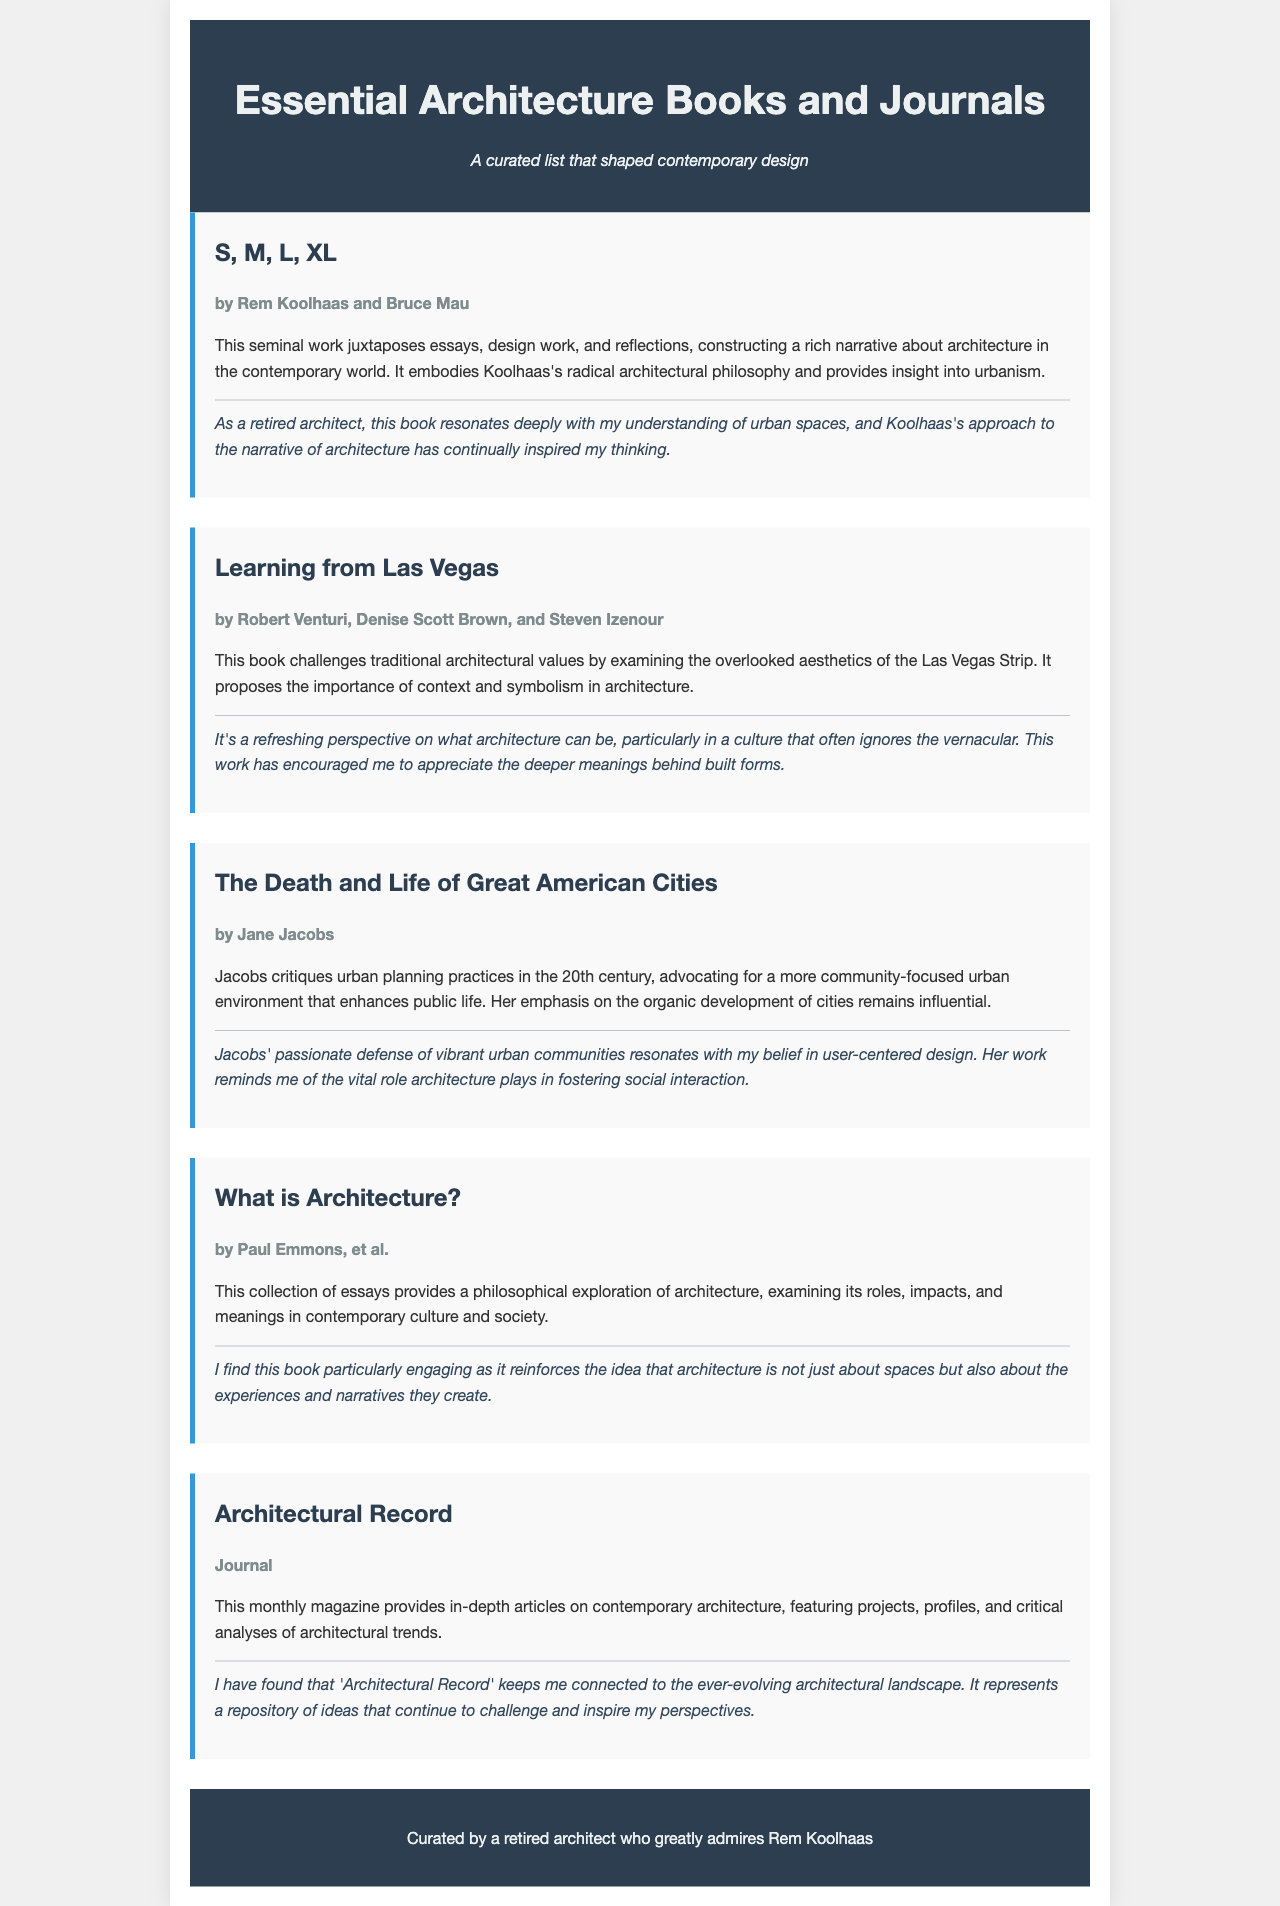What is the title of the book by Rem Koolhaas? The title of the book authored by Rem Koolhaas is prominently mentioned in the document under his section.
Answer: S, M, L, XL Who co-authored "Learning from Las Vegas"? The authors of "Learning from Las Vegas" are listed in the document, which specifies Robert Venturi, Denise Scott Brown, and Steven Izenour as the creators of this work.
Answer: Robert Venturi, Denise Scott Brown, and Steven Izenour What is the main focus of "The Death and Life of Great American Cities"? The document summarizes this work with a focus on critiquing urban planning and emphasizing community in urban environments; hence, it can be deduced.
Answer: Community-focused urban environment Which journal is mentioned in the document? The document includes the name of a monthly publication that features articles on contemporary architecture, specifically noted as a journal.
Answer: Architectural Record What theme is recurrent in the reflections of the book summaries? Each reflection expresses a connection between architecture and a certain concept or aspect, providing insight into the author's perspective about architecture's impact.
Answer: User-centered design How many authors are mentioned for "What is Architecture?" The document explicitly states that "What is Architecture?" is authored by Paul Emmons et al., which indicates the presence of multiple authors.
Answer: Multiple authors What is the unique feature of the book "S, M, L, XL"? The document describes "S, M, L, XL" as a work that juxtaposes different elements, signifying a unique structural narrative style.
Answer: Juxtaposes essays, design work, and reflections What is the publication frequency of "Architectural Record"? Within the document, it specifies the frequency of this journal, indicating how often it's released to the audience.
Answer: Monthly 